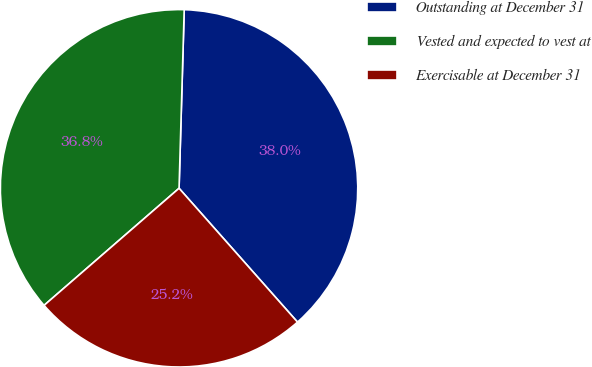<chart> <loc_0><loc_0><loc_500><loc_500><pie_chart><fcel>Outstanding at December 31<fcel>Vested and expected to vest at<fcel>Exercisable at December 31<nl><fcel>38.01%<fcel>36.83%<fcel>25.16%<nl></chart> 